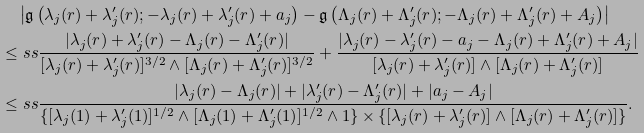Convert formula to latex. <formula><loc_0><loc_0><loc_500><loc_500>& \quad \left | \mathfrak g \left ( \lambda _ { j } ( r ) + \lambda ^ { \prime } _ { j } ( r ) ; - \lambda _ { j } ( r ) + \lambda ^ { \prime } _ { j } ( r ) + a _ { j } \right ) - \mathfrak g \left ( \Lambda _ { j } ( r ) + \Lambda ^ { \prime } _ { j } ( r ) ; - \Lambda _ { j } ( r ) + \Lambda ^ { \prime } _ { j } ( r ) + A _ { j } \right ) \right | \\ & \leq s s \frac { | \lambda _ { j } ( r ) + \lambda ^ { \prime } _ { j } ( r ) - \Lambda _ { j } ( r ) - \Lambda ^ { \prime } _ { j } ( r ) | } { [ \lambda _ { j } ( r ) + \lambda ^ { \prime } _ { j } ( r ) ] ^ { 3 / 2 } \wedge [ \Lambda _ { j } ( r ) + \Lambda ^ { \prime } _ { j } ( r ) ] ^ { 3 / 2 } } + \frac { | \lambda _ { j } ( r ) - \lambda ^ { \prime } _ { j } ( r ) - a _ { j } - \Lambda _ { j } ( r ) + \Lambda ^ { \prime } _ { j } ( r ) + A _ { j } | } { [ \lambda _ { j } ( r ) + \lambda ^ { \prime } _ { j } ( r ) ] \wedge [ \Lambda _ { j } ( r ) + \Lambda ^ { \prime } _ { j } ( r ) ] } \\ & \leq s s \frac { | \lambda _ { j } ( r ) - \Lambda _ { j } ( r ) | + | \lambda ^ { \prime } _ { j } ( r ) - \Lambda ^ { \prime } _ { j } ( r ) | + | a _ { j } - A _ { j } | } { \{ [ \lambda _ { j } ( 1 ) + \lambda ^ { \prime } _ { j } ( 1 ) ] ^ { 1 / 2 } \wedge [ \Lambda _ { j } ( 1 ) + \Lambda ^ { \prime } _ { j } ( 1 ) ] ^ { 1 / 2 } \wedge 1 \} \times \{ [ \lambda _ { j } ( r ) + \lambda ^ { \prime } _ { j } ( r ) ] \wedge [ \Lambda _ { j } ( r ) + \Lambda ^ { \prime } _ { j } ( r ) ] \} } .</formula> 